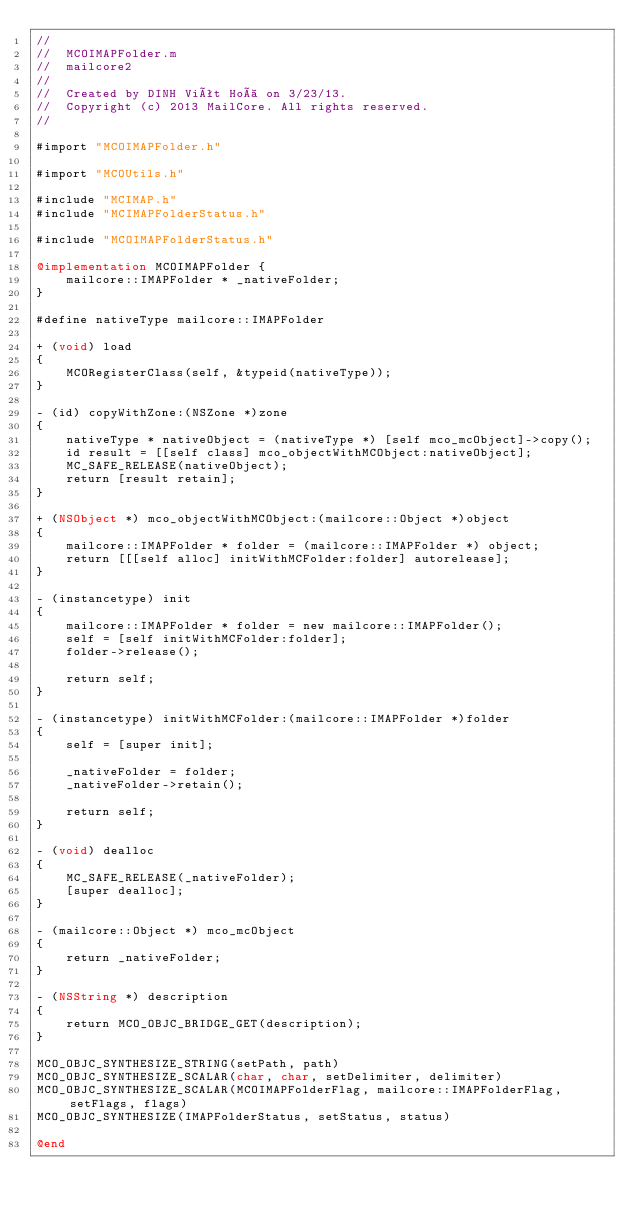Convert code to text. <code><loc_0><loc_0><loc_500><loc_500><_ObjectiveC_>//
//  MCOIMAPFolder.m
//  mailcore2
//
//  Created by DINH Viêt Hoà on 3/23/13.
//  Copyright (c) 2013 MailCore. All rights reserved.
//

#import "MCOIMAPFolder.h"

#import "MCOUtils.h"

#include "MCIMAP.h"
#include "MCIMAPFolderStatus.h"

#include "MCOIMAPFolderStatus.h"

@implementation MCOIMAPFolder {
    mailcore::IMAPFolder * _nativeFolder;
}

#define nativeType mailcore::IMAPFolder

+ (void) load
{
    MCORegisterClass(self, &typeid(nativeType));
}

- (id) copyWithZone:(NSZone *)zone
{
    nativeType * nativeObject = (nativeType *) [self mco_mcObject]->copy();
    id result = [[self class] mco_objectWithMCObject:nativeObject];
    MC_SAFE_RELEASE(nativeObject);
    return [result retain];
}

+ (NSObject *) mco_objectWithMCObject:(mailcore::Object *)object
{
    mailcore::IMAPFolder * folder = (mailcore::IMAPFolder *) object;
    return [[[self alloc] initWithMCFolder:folder] autorelease];
}

- (instancetype) init
{
    mailcore::IMAPFolder * folder = new mailcore::IMAPFolder();
    self = [self initWithMCFolder:folder];
    folder->release();
    
    return self;
}

- (instancetype) initWithMCFolder:(mailcore::IMAPFolder *)folder
{
    self = [super init];
    
    _nativeFolder = folder;
    _nativeFolder->retain();
    
    return self;
}

- (void) dealloc
{
    MC_SAFE_RELEASE(_nativeFolder);
    [super dealloc];
}

- (mailcore::Object *) mco_mcObject
{
    return _nativeFolder;
}

- (NSString *) description
{
    return MCO_OBJC_BRIDGE_GET(description);
}

MCO_OBJC_SYNTHESIZE_STRING(setPath, path)
MCO_OBJC_SYNTHESIZE_SCALAR(char, char, setDelimiter, delimiter)
MCO_OBJC_SYNTHESIZE_SCALAR(MCOIMAPFolderFlag, mailcore::IMAPFolderFlag, setFlags, flags)
MCO_OBJC_SYNTHESIZE(IMAPFolderStatus, setStatus, status)

@end
</code> 